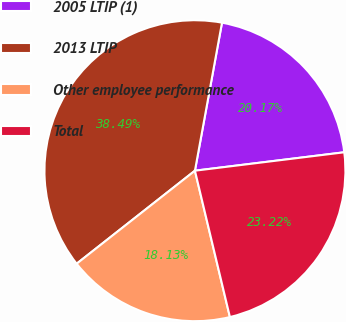Convert chart. <chart><loc_0><loc_0><loc_500><loc_500><pie_chart><fcel>2005 LTIP (1)<fcel>2013 LTIP<fcel>Other employee performance<fcel>Total<nl><fcel>20.17%<fcel>38.49%<fcel>18.13%<fcel>23.22%<nl></chart> 